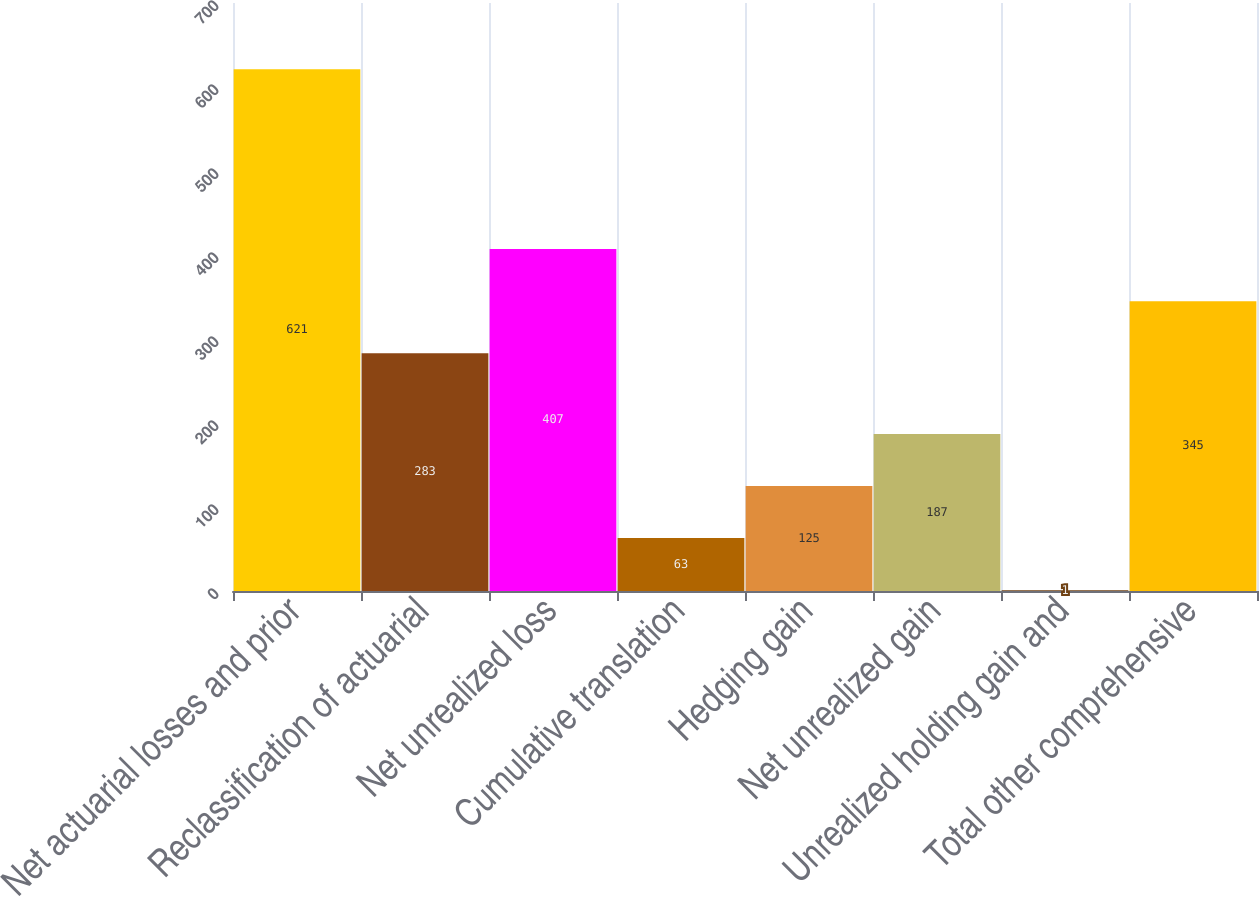Convert chart to OTSL. <chart><loc_0><loc_0><loc_500><loc_500><bar_chart><fcel>Net actuarial losses and prior<fcel>Reclassification of actuarial<fcel>Net unrealized loss<fcel>Cumulative translation<fcel>Hedging gain<fcel>Net unrealized gain<fcel>Unrealized holding gain and<fcel>Total other comprehensive<nl><fcel>621<fcel>283<fcel>407<fcel>63<fcel>125<fcel>187<fcel>1<fcel>345<nl></chart> 